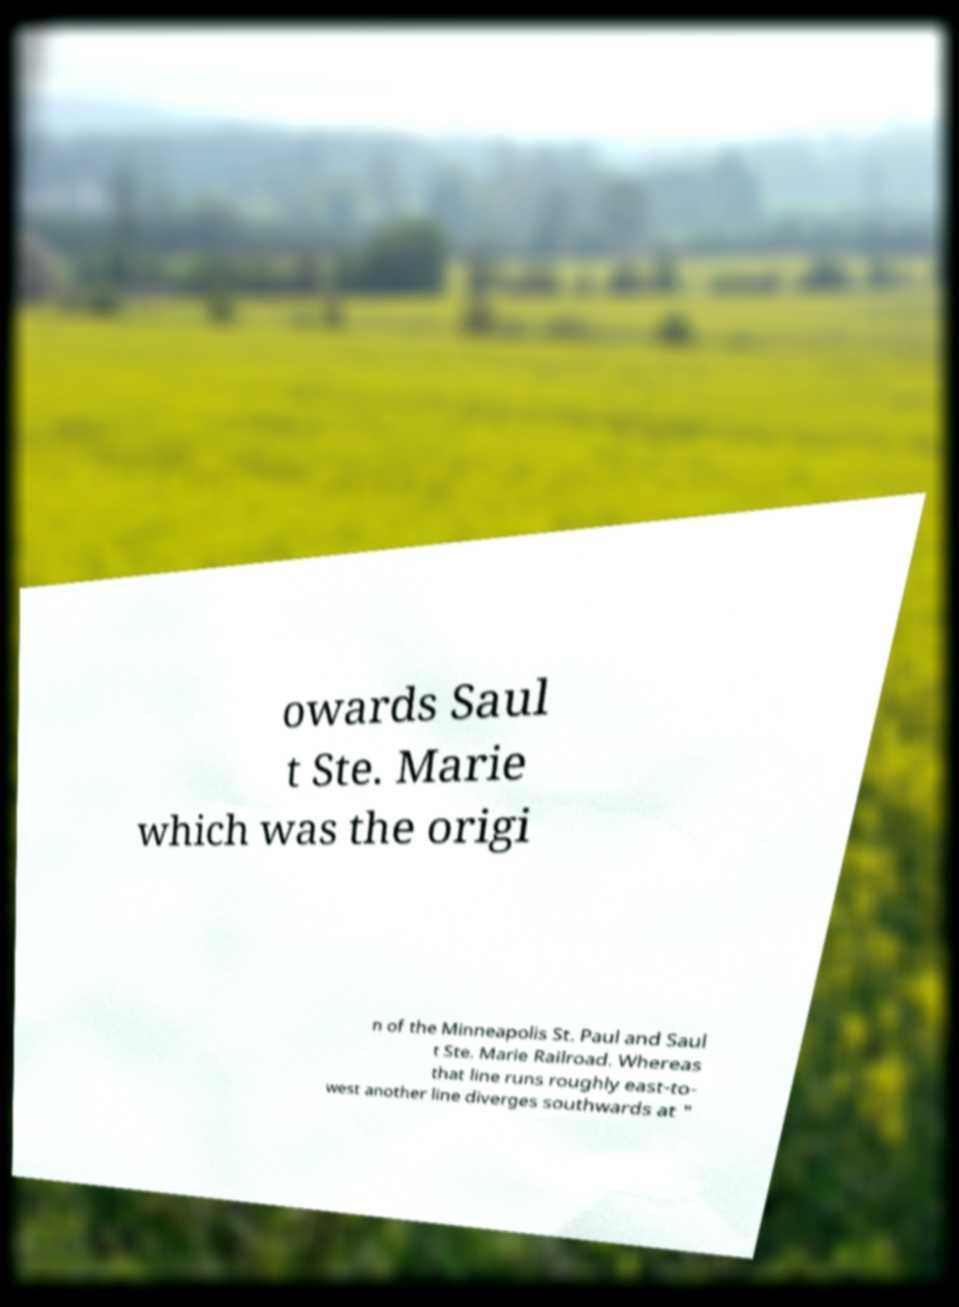For documentation purposes, I need the text within this image transcribed. Could you provide that? owards Saul t Ste. Marie which was the origi n of the Minneapolis St. Paul and Saul t Ste. Marie Railroad. Whereas that line runs roughly east-to- west another line diverges southwards at " 